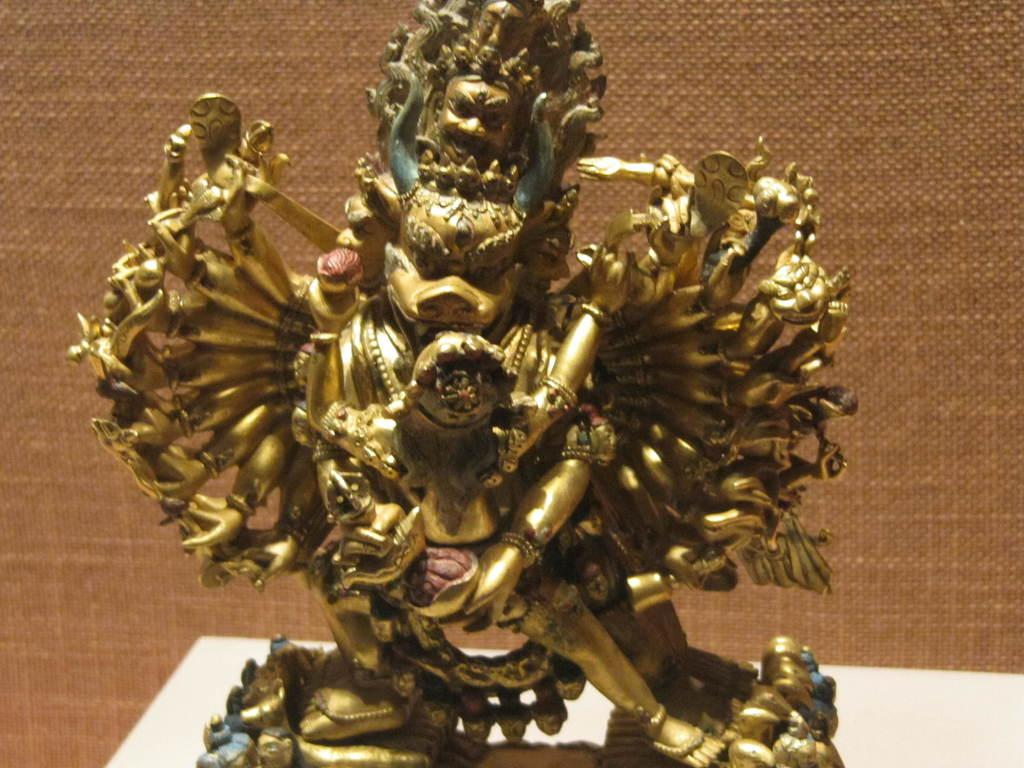What is the main subject of the image? There is a sculpture in the image. Where is the sculpture located? The sculpture is on a table. How many spiders are crawling on the toes of the sculpture in the image? There are no spiders or toes present in the image, as it features a sculpture on a table. 